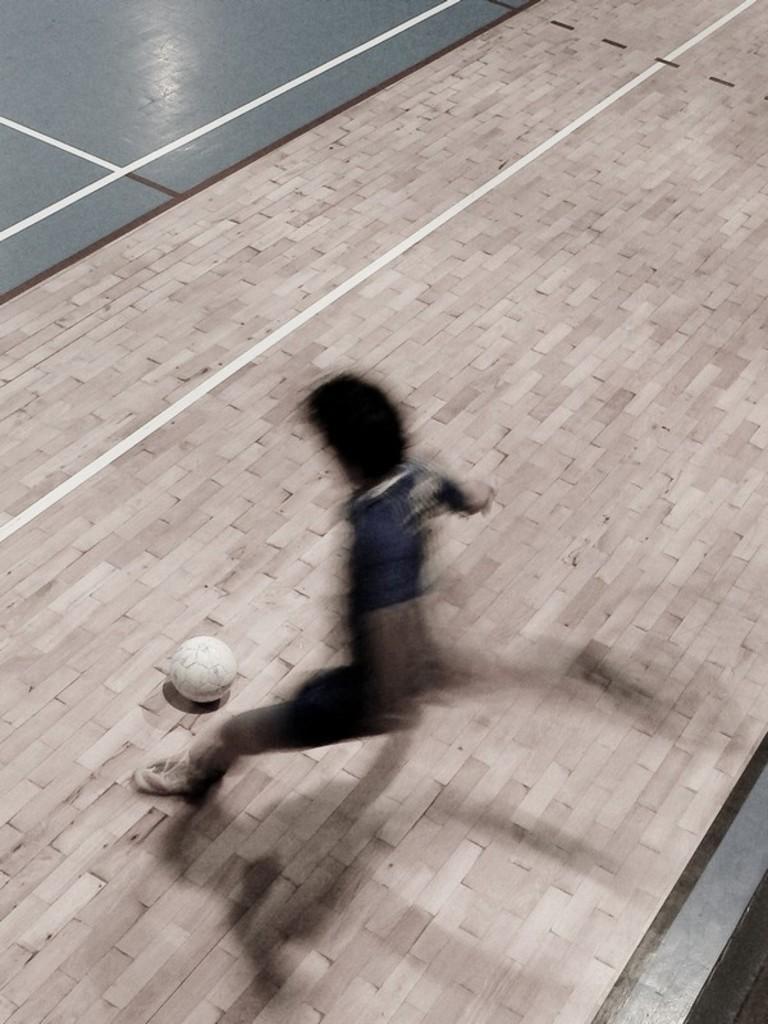In one or two sentences, can you explain what this image depicts? In this image I can see a blurry person and a white colour football. On the top side of this image I can see few lines on the floor. 